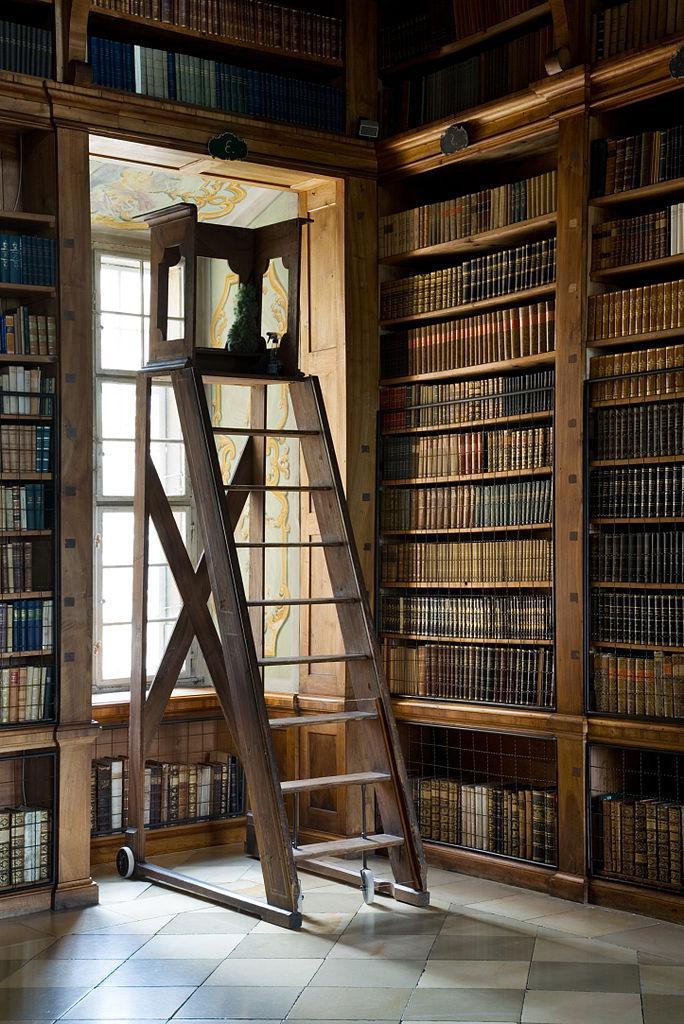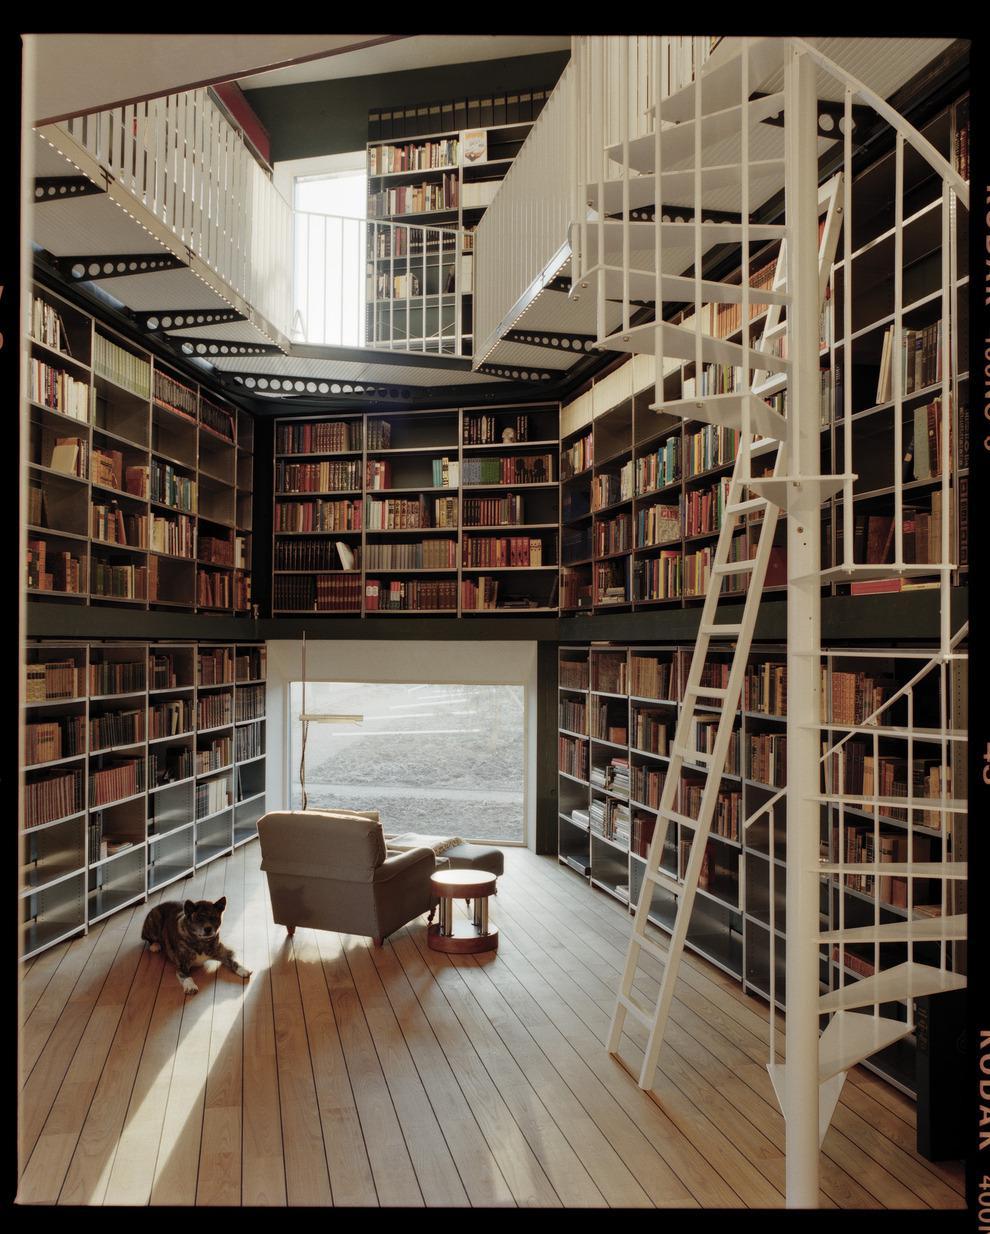The first image is the image on the left, the second image is the image on the right. Analyze the images presented: Is the assertion "There is exactly one ladder." valid? Answer yes or no. No. The first image is the image on the left, the second image is the image on the right. For the images displayed, is the sentence "The right image shows a white ladder leaned against an upper shelf of a bookcase." factually correct? Answer yes or no. Yes. 